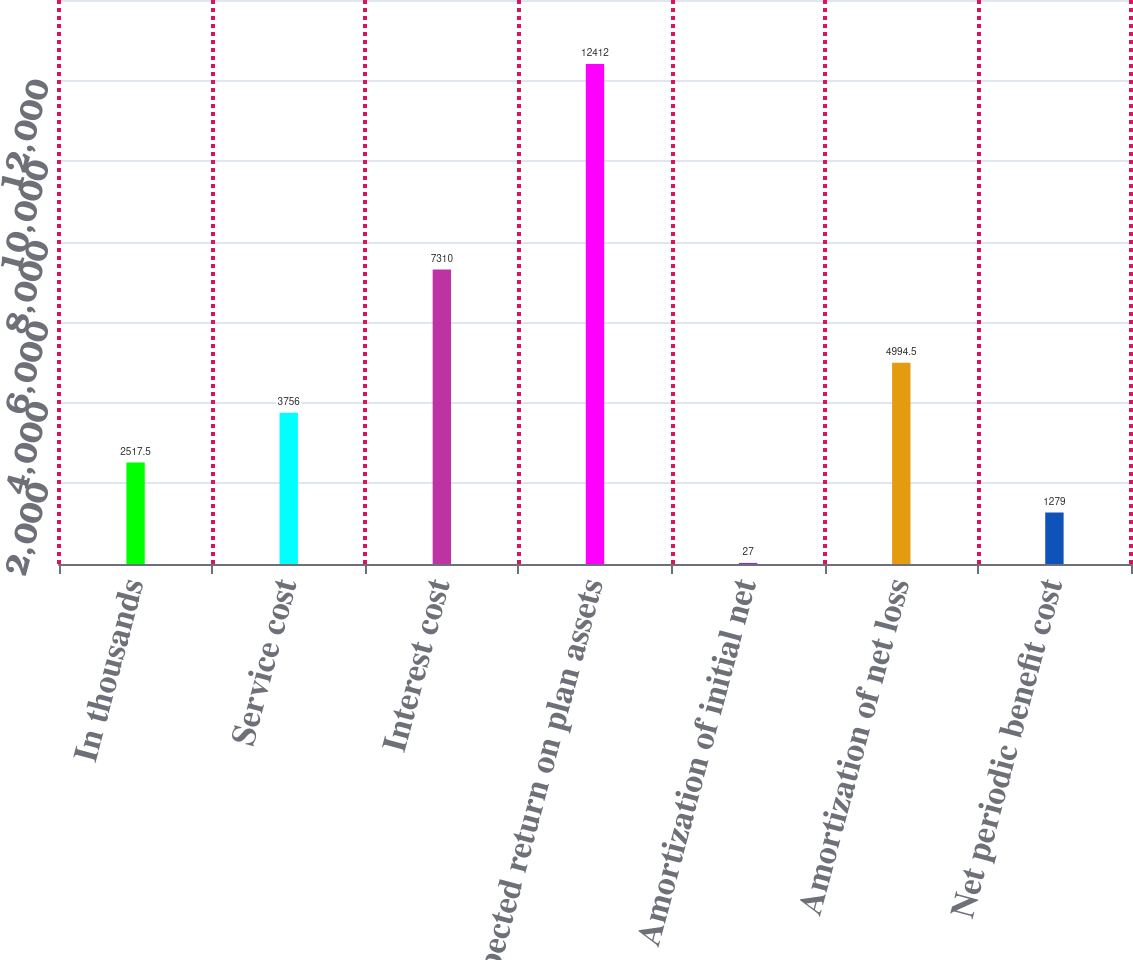Convert chart. <chart><loc_0><loc_0><loc_500><loc_500><bar_chart><fcel>In thousands<fcel>Service cost<fcel>Interest cost<fcel>Expected return on plan assets<fcel>Amortization of initial net<fcel>Amortization of net loss<fcel>Net periodic benefit cost<nl><fcel>2517.5<fcel>3756<fcel>7310<fcel>12412<fcel>27<fcel>4994.5<fcel>1279<nl></chart> 